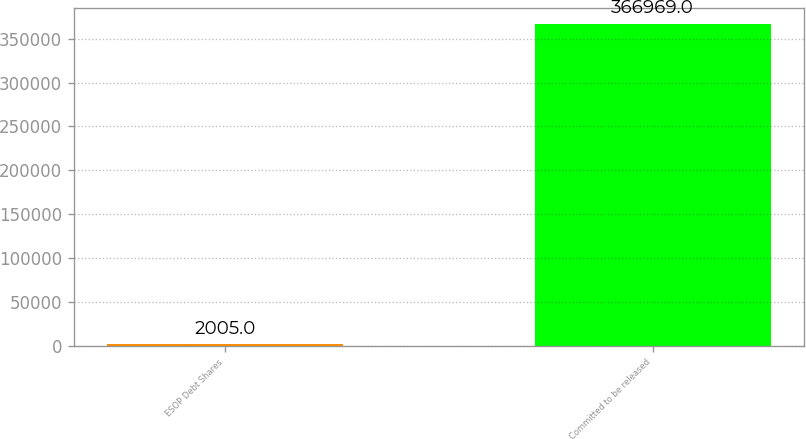Convert chart to OTSL. <chart><loc_0><loc_0><loc_500><loc_500><bar_chart><fcel>ESOP Debt Shares<fcel>Committed to be released<nl><fcel>2005<fcel>366969<nl></chart> 